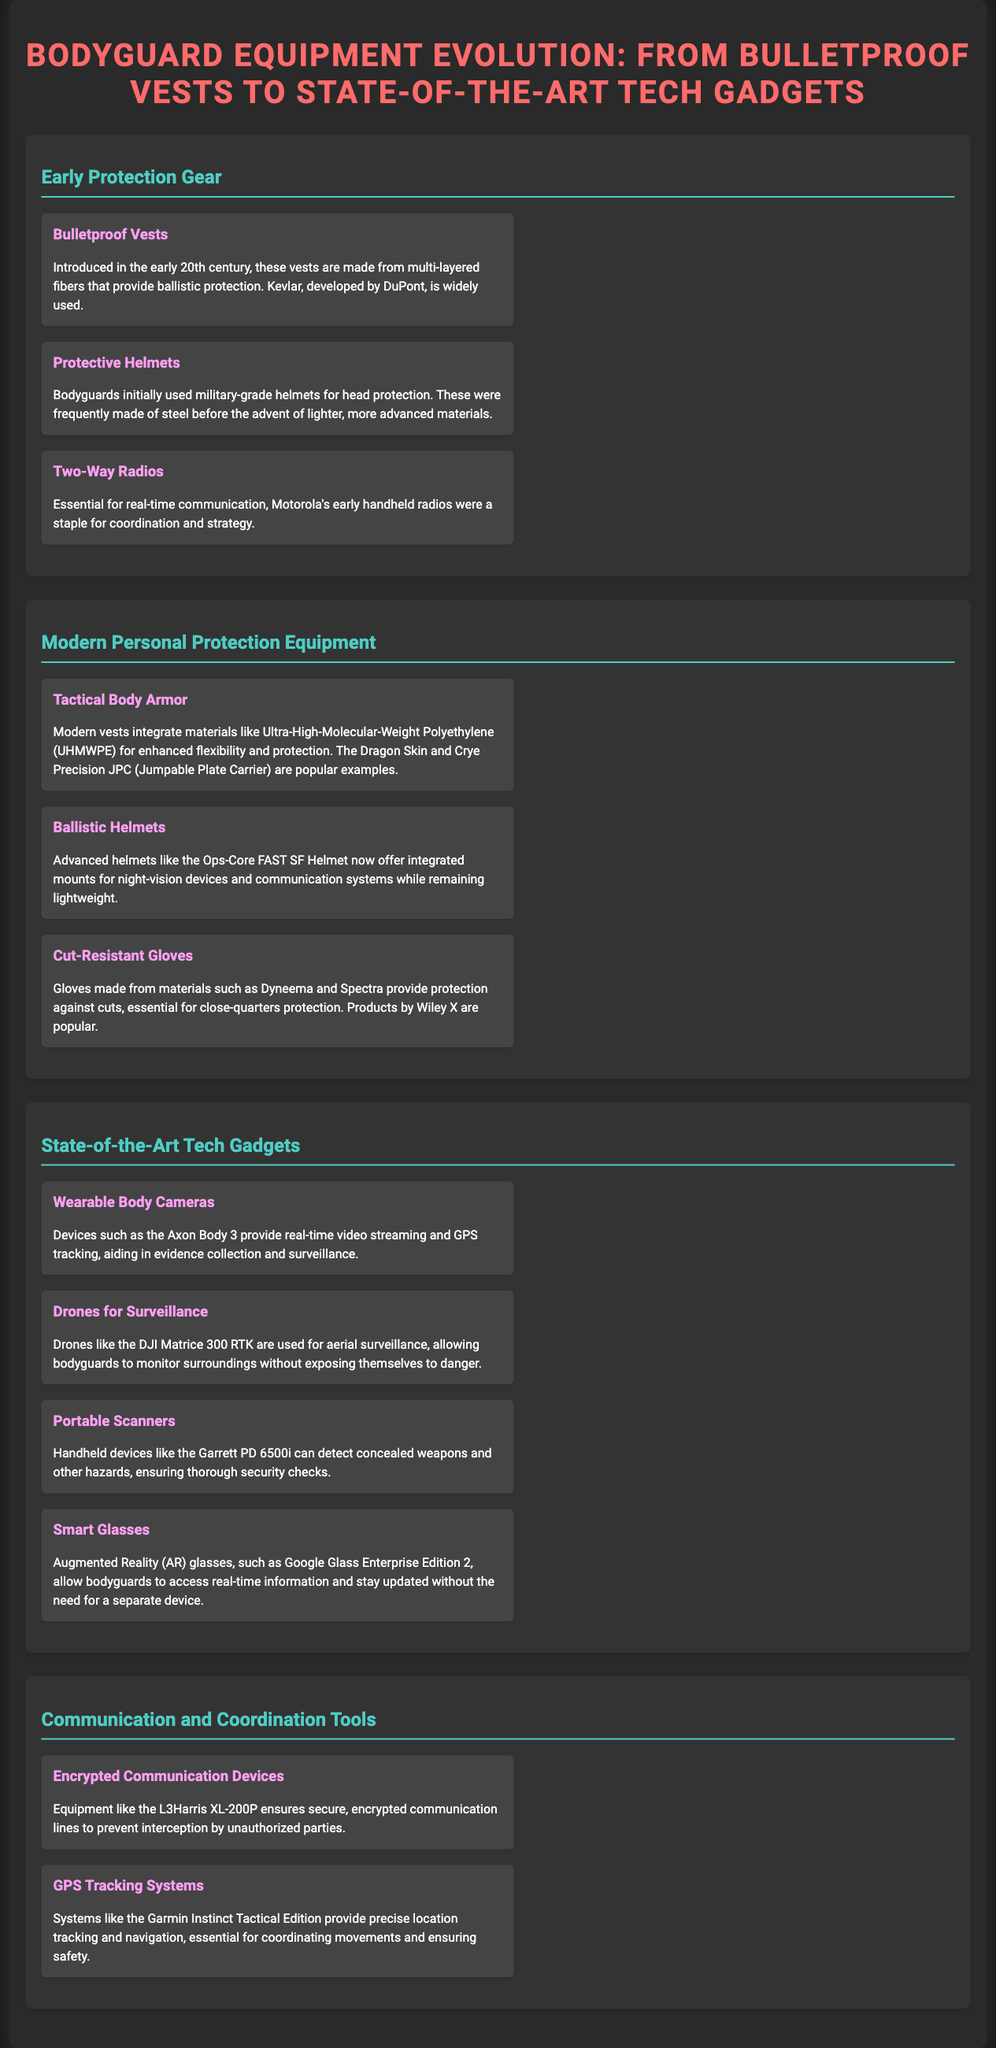What material is widely used in bulletproof vests? The document mentions that Kevlar, developed by DuPont, is widely used in bulletproof vests.
Answer: Kevlar What type of armor integrates Ultra-High-Molecular-Weight Polyethylene? The document states that modern Tactical Body Armor integrates Ultra-High-Molecular-Weight Polyethylene (UHMWPE) for enhanced flexibility and protection.
Answer: Tactical Body Armor Which helmet offers integrated mounts for night-vision devices? The document highlights that the Ops-Core FAST SF Helmet offers integrated mounts for night-vision devices.
Answer: Ops-Core FAST SF Helmet What is the main function of wearable body cameras like the Axon Body 3? The document explains that devices like the Axon Body 3 provide real-time video streaming and GPS tracking.
Answer: Evidence collection and surveillance What device ensures secure, encrypted communication lines? The document mentions that the L3Harris XL-200P ensures secure, encrypted communication lines.
Answer: L3Harris XL-200P How do drones assist bodyguards according to the document? Drones, such as the DJI Matrice 300 RTK, are utilized for aerial surveillance to monitor surroundings.
Answer: Aerial surveillance What equipment is used to detect concealed weapons? The document states that handheld devices like the Garrett PD 6500i can detect concealed weapons.
Answer: Garrett PD 6500i What type of gloves offer cut protection? The document mentions gloves made from materials such as Dyneema and Spectra provide cut protection.
Answer: Cut-Resistant Gloves Which smart glasses allow bodyguards to access real-time information? The document indicates that Google Glass Enterprise Edition 2 allows access to real-time information.
Answer: Google Glass Enterprise Edition 2 